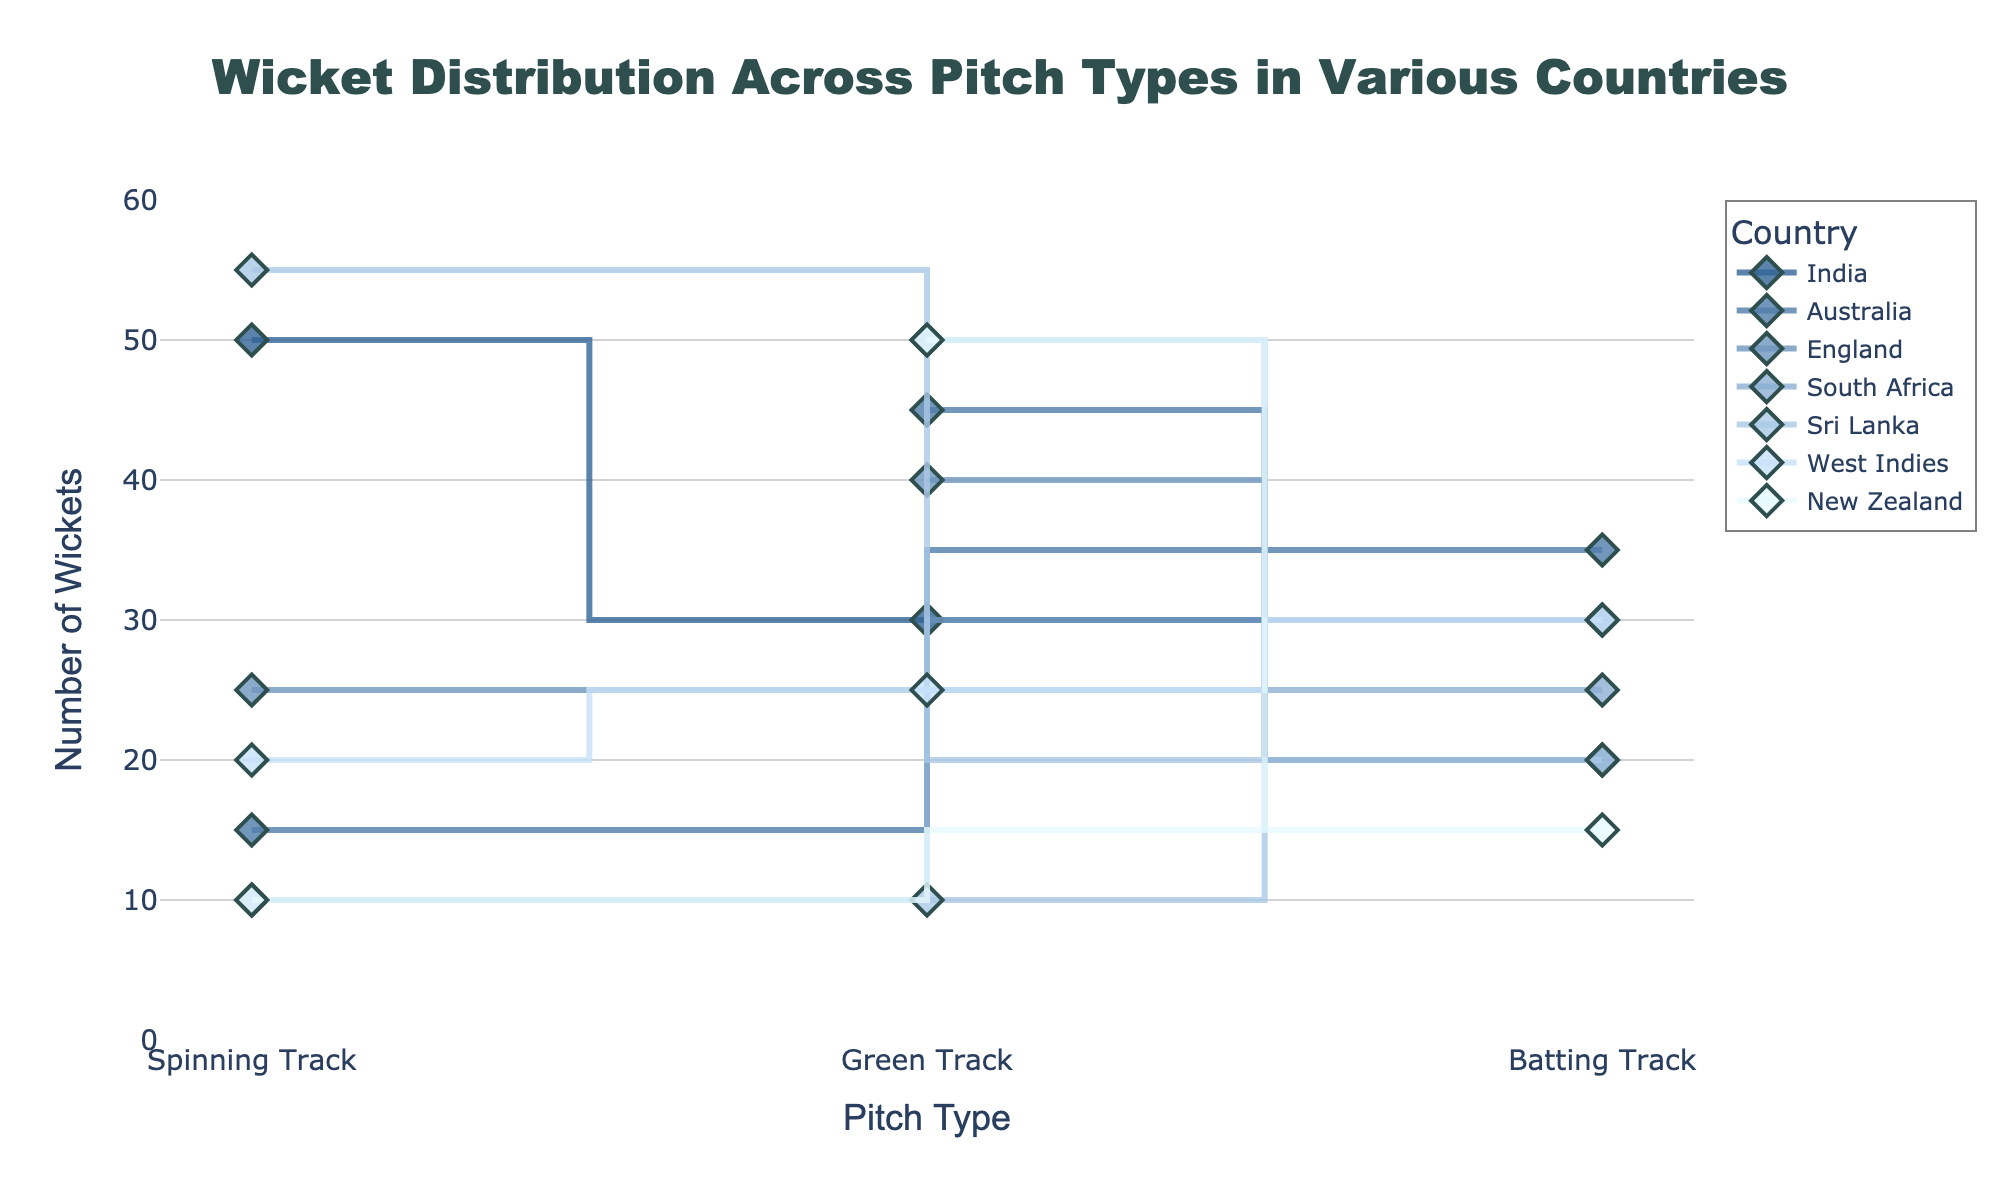What's the title of the figure? The title of the figure is usually displayed at the top of the plot. Looking at the top of the figure tells us the title.
Answer: Wicket Distribution Across Pitch Types in Various Countries Which axis shows the number of wickets? The axis that shows the number of wickets is the vertical one, generally labeled with a title that says "Number of Wickets". The y-axis title in this figure shows this.
Answer: Y-axis Which country has the highest number of wickets on a spinning track? To find this, check the line or marker that reaches the highest point on the y-axis for the spinning track on the x-axis. The highest point corresponds to Sri Lanka with 55 wickets.
Answer: Sri Lanka How many wickets did Australia take on green tracks? Look for the data points related to Australia and locate the one corresponding to the green track on the x-axis, then check the y-axis value. The value is 45 wickets.
Answer: 45 Which pitch type in England recorded the least wickets? Check England's markers on the plot and find the lowest value on the y-axis. The spinning track has the lowest value of 25 wickets.
Answer: Spinning Track What is the sum of wickets taken by South Africa on batting and green tracks? First, find the values for batting and green tracks in South Africa, which are 25 and 50 respectively. Add these values together. 25 + 50 = 75.
Answer: 75 Compare the number of wickets on batting tracks between New Zealand and West Indies. Which country has more, and by how much? Identify the number of wickets for these countries on batting tracks—New Zealand has 15, and West Indies has 30. The difference is 30 - 15 = 15, so West Indies has 15 more wickets than New Zealand.
Answer: West Indies by 15 What is the average number of wickets taken on green tracks across all countries shown? Sum the wickets for green tracks across all countries and divide by the number of countries. Values are 30 + 45 + 40 + 50 + 10 + 25 + 50 = 250, and there are 7 countries. 250 / 7 ≈ 35.71.
Answer: Approximately 35.71 Which pitch type in India recorded the fewest wickets? Check India's markers and find the lowest y-axis value among the pitch types. Batting Track has the lowest value of 20 wickets.
Answer: Batting Track 